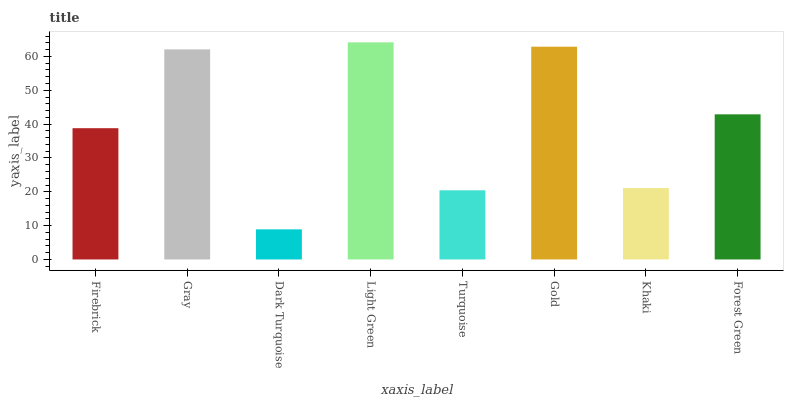Is Dark Turquoise the minimum?
Answer yes or no. Yes. Is Light Green the maximum?
Answer yes or no. Yes. Is Gray the minimum?
Answer yes or no. No. Is Gray the maximum?
Answer yes or no. No. Is Gray greater than Firebrick?
Answer yes or no. Yes. Is Firebrick less than Gray?
Answer yes or no. Yes. Is Firebrick greater than Gray?
Answer yes or no. No. Is Gray less than Firebrick?
Answer yes or no. No. Is Forest Green the high median?
Answer yes or no. Yes. Is Firebrick the low median?
Answer yes or no. Yes. Is Light Green the high median?
Answer yes or no. No. Is Turquoise the low median?
Answer yes or no. No. 